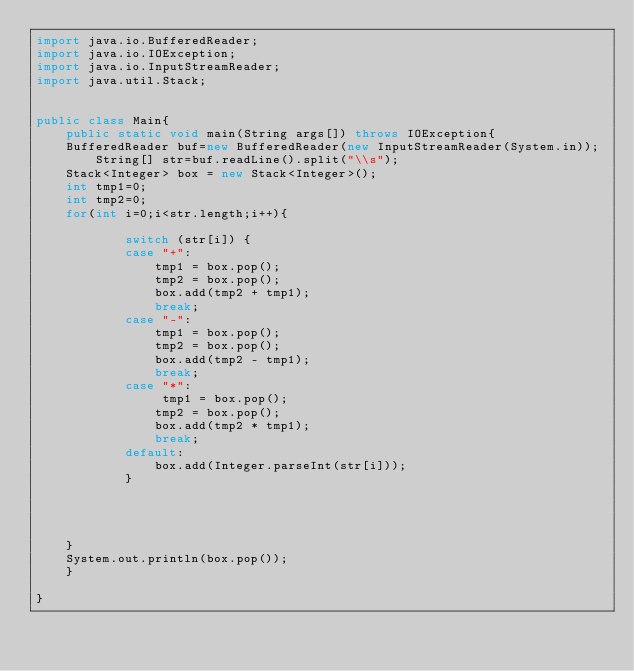<code> <loc_0><loc_0><loc_500><loc_500><_Java_>import java.io.BufferedReader;
import java.io.IOException;
import java.io.InputStreamReader;
import java.util.Stack;


public class Main{
    public static void main(String args[]) throws IOException{
	BufferedReader buf=new BufferedReader(new InputStreamReader(System.in));
        String[] str=buf.readLine().split("\\s");
	Stack<Integer> box = new Stack<Integer>();
	int tmp1=0;
	int tmp2=0;
	for(int i=0;i<str.length;i++){
	   
	        switch (str[i]) {
            case "+":
                tmp1 = box.pop();
                tmp2 = box.pop();
                box.add(tmp2 + tmp1);
                break;
            case "-":
                tmp1 = box.pop();
                tmp2 = box.pop();
                box.add(tmp2 - tmp1);
                break;
            case "*":
                 tmp1 = box.pop();
                tmp2 = box.pop();
                box.add(tmp2 * tmp1);
                break;
            default:
                box.add(Integer.parseInt(str[i]));
            }

	    

						       
	}
	System.out.println(box.pop());
    }
 
}

</code> 